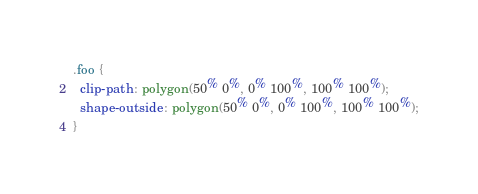Convert code to text. <code><loc_0><loc_0><loc_500><loc_500><_CSS_>.foo {
  clip-path: polygon(50% 0%, 0% 100%, 100% 100%);
  shape-outside: polygon(50% 0%, 0% 100%, 100% 100%);
}</code> 